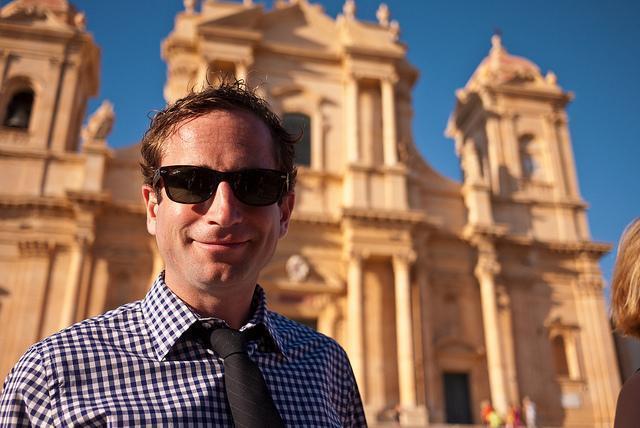How many ties are there?
Give a very brief answer. 1. How many people are there?
Give a very brief answer. 2. 